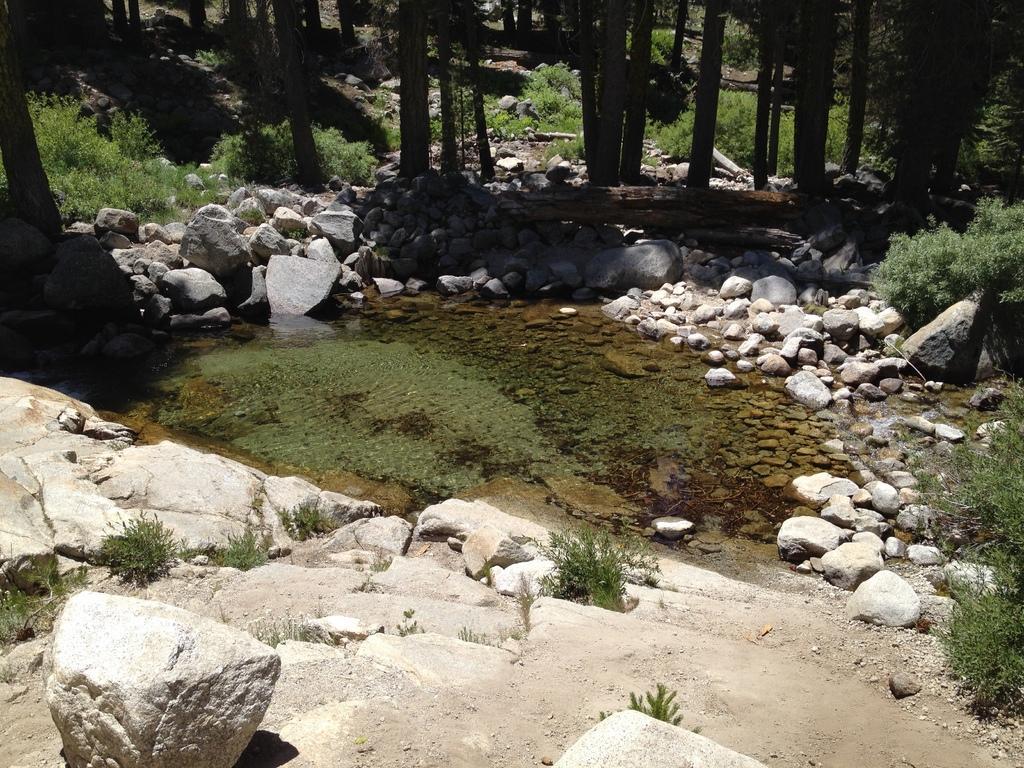Please provide a concise description of this image. In the foreground of the image we can see rocks. In the middle of the image we can see rocks and some water body. On the top of the image we can see trees. 